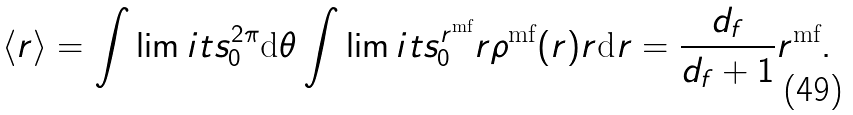<formula> <loc_0><loc_0><loc_500><loc_500>\langle r \rangle = \int \lim i t s _ { 0 } ^ { 2 \pi } \text {d} \theta \int \lim i t s _ { 0 } ^ { r ^ { \text {mf} } } r \rho ^ { \text {mf} } ( r ) r \text {d} r = \frac { d _ { f } } { d _ { f } + 1 } r ^ { \text {mf} } .</formula> 